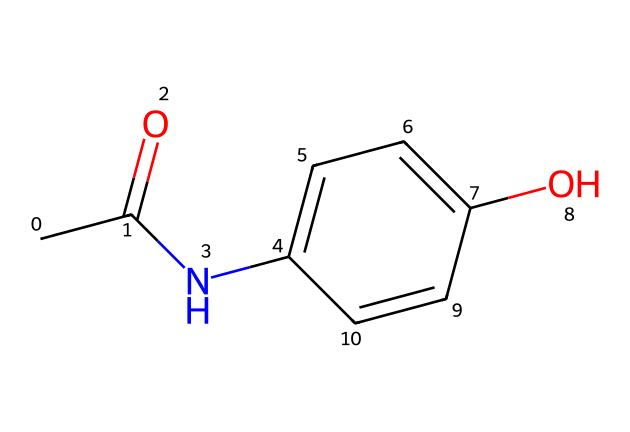How many carbon atoms are present in this molecule? To find the number of carbon atoms, we look for the 'C' symbols in the SMILES representation. Counting yields a total of 8 carbon atoms.
Answer: 8 What functional group is present in paracetamol? The SMILES notation shows a hydroxyl group (-OH) and an amide group (-NH-C(=O)-). The presence of the hydroxyl group indicates that it is a phenol, and the amide group characterizes it as an acetanilide.
Answer: hydroxyl and amide What is the total number of hydrogen atoms in paracetamol? In the SMILES notation, each carbon generally bonds with enough hydrogens to have four total bonds. Total hydrogen atoms can be deduced by calculating hydrogens bonded to carbons and accounting for other elements. The final count gives us 9 hydrogen atoms.
Answer: 9 Which part of this molecule indicates it is a phenol? The presence of the hydroxyl group (-OH) attached to the aromatic ring (the benzene part) indicates that this molecule is a phenol. The -OH group bonds directly with the aromatic carbon.
Answer: the hydroxyl group What is the significance of the acetyl group in paracetamol? The acetyl group (CC(=O)-) is important as it contributes to the drug's analgesic properties and modulates its metabolism in the body. It's essential for the activity of paracetamol as a pain reliever.
Answer: analgesic properties How does the arrangement of atoms affect the solubility of paracetamol? The hydrogen bond potential of the hydroxyl group helps paracetamol dissolve in water, while the acetyl group balances its lipophilicity. This combination allows for a moderate level of water solubility.
Answer: moderate solubility 